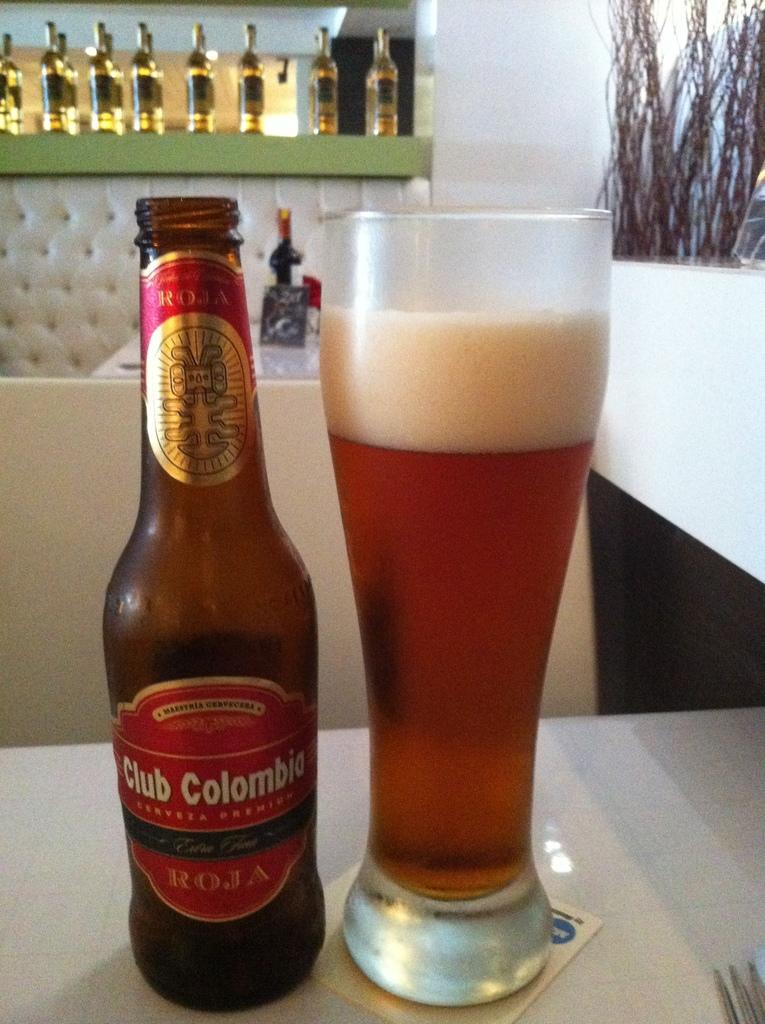<image>
Write a terse but informative summary of the picture. A brown bottle of Club Columbia beer sitting next to a glass of beer on a table in a restaurant. 